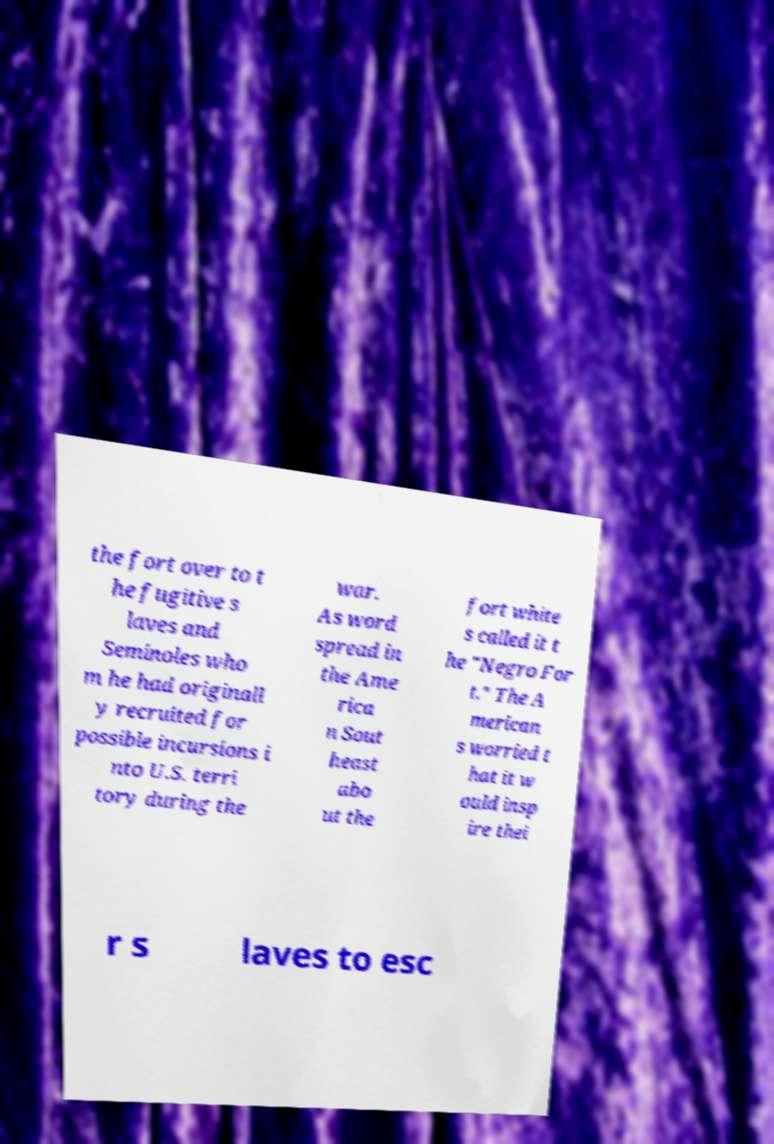I need the written content from this picture converted into text. Can you do that? the fort over to t he fugitive s laves and Seminoles who m he had originall y recruited for possible incursions i nto U.S. terri tory during the war. As word spread in the Ame rica n Sout heast abo ut the fort white s called it t he "Negro For t." The A merican s worried t hat it w ould insp ire thei r s laves to esc 